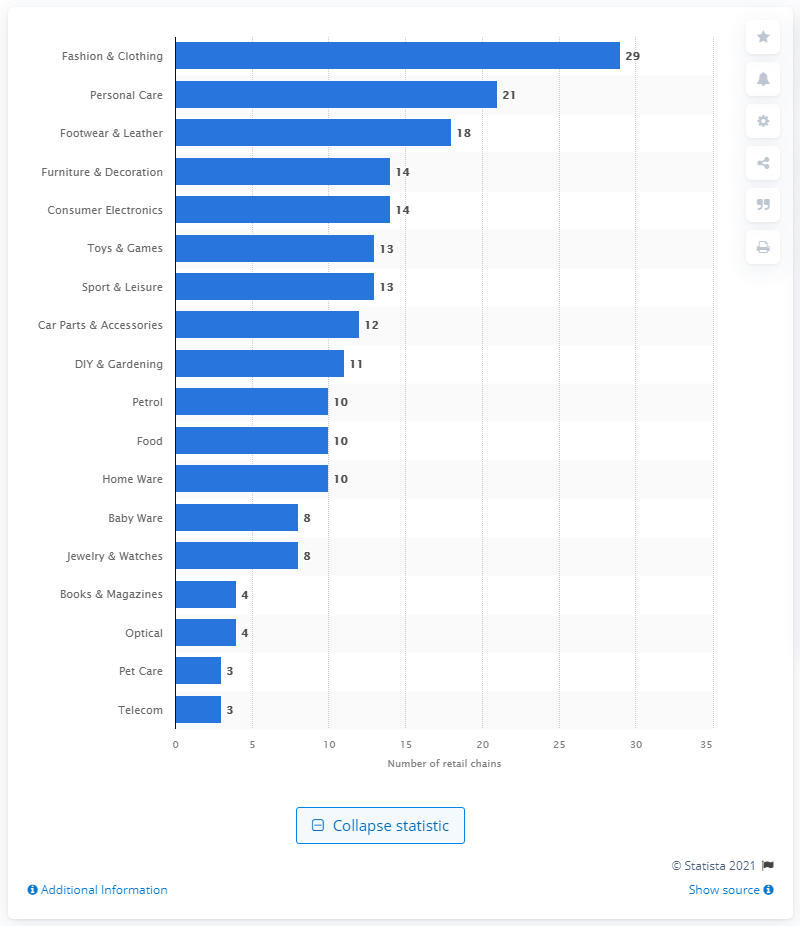Draw attention to some important aspects in this diagram. There were 18 retail chains in Romania in 2021. There were 21 retail chains in Romania in 2021. 